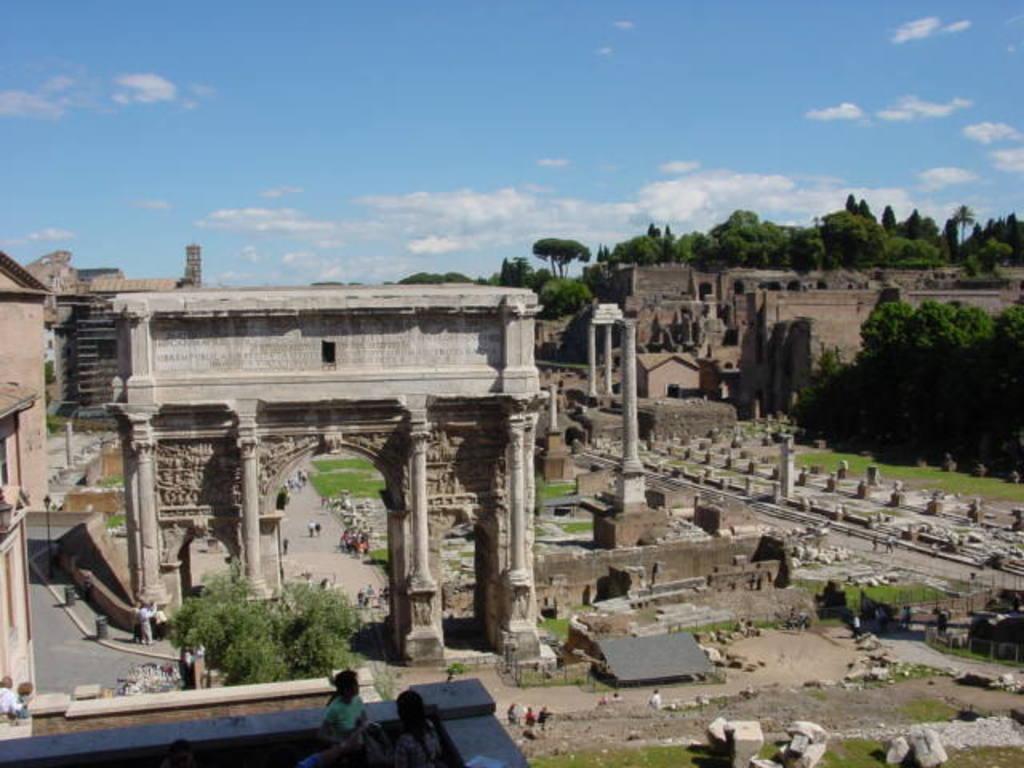Could you give a brief overview of what you see in this image? In this image, in the middle there are trees, fort, pillars, stones, grass, people, buildings, road, sky and clouds. 